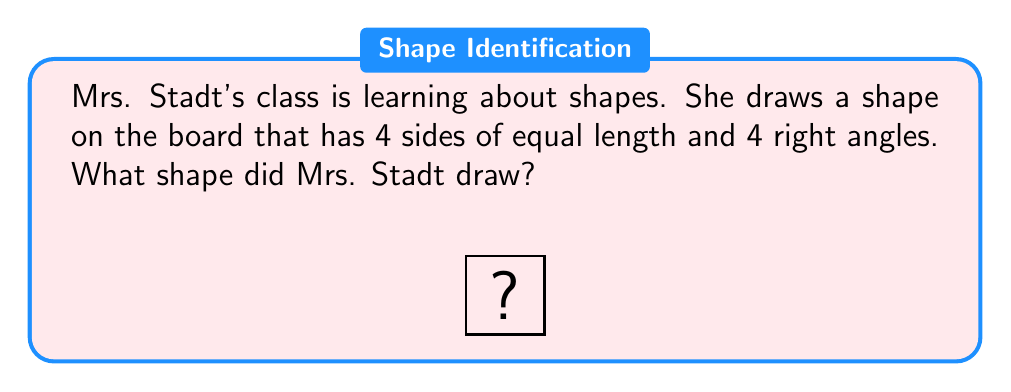Teach me how to tackle this problem. Let's analyze the properties of the shape Mrs. Stadt drew:

1. It has 4 sides: This narrows it down to quadrilaterals.
2. All sides are of equal length: This eliminates rectangles (unless they're squares) and irregular quadrilaterals.
3. It has 4 right angles: This eliminates rhombuses and parallelograms (unless they're rectangles or squares).

The only shape that satisfies all these conditions is a square. A square is defined as a quadrilateral with four equal sides and four right angles.

Other shapes we can rule out:
- Rectangle: Has 4 right angles but not all sides are equal (unless it's a square).
- Rhombus: Has 4 equal sides but not necessarily right angles.
- Parallelogram: Opposite sides are parallel but not necessarily equal or at right angles.

Therefore, the shape Mrs. Stadt drew on the board must be a square.
Answer: Square 